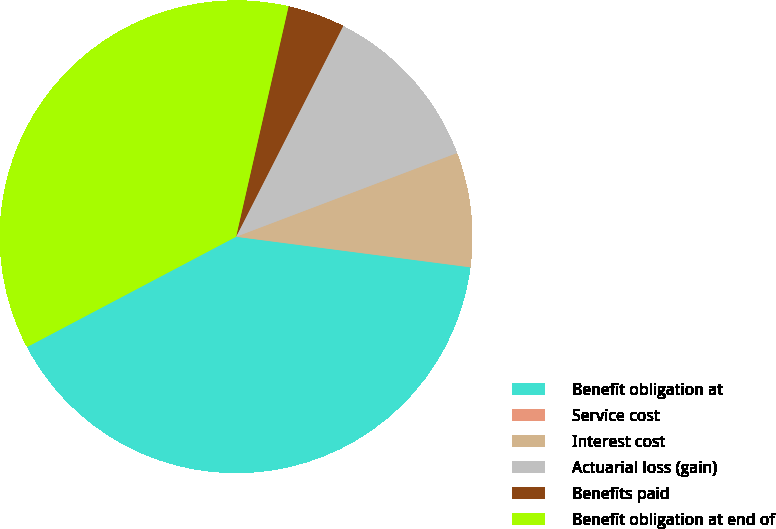Convert chart. <chart><loc_0><loc_0><loc_500><loc_500><pie_chart><fcel>Benefit obligation at<fcel>Service cost<fcel>Interest cost<fcel>Actuarial loss (gain)<fcel>Benefits paid<fcel>Benefit obligation at end of<nl><fcel>40.21%<fcel>0.0%<fcel>7.83%<fcel>11.75%<fcel>3.92%<fcel>36.29%<nl></chart> 